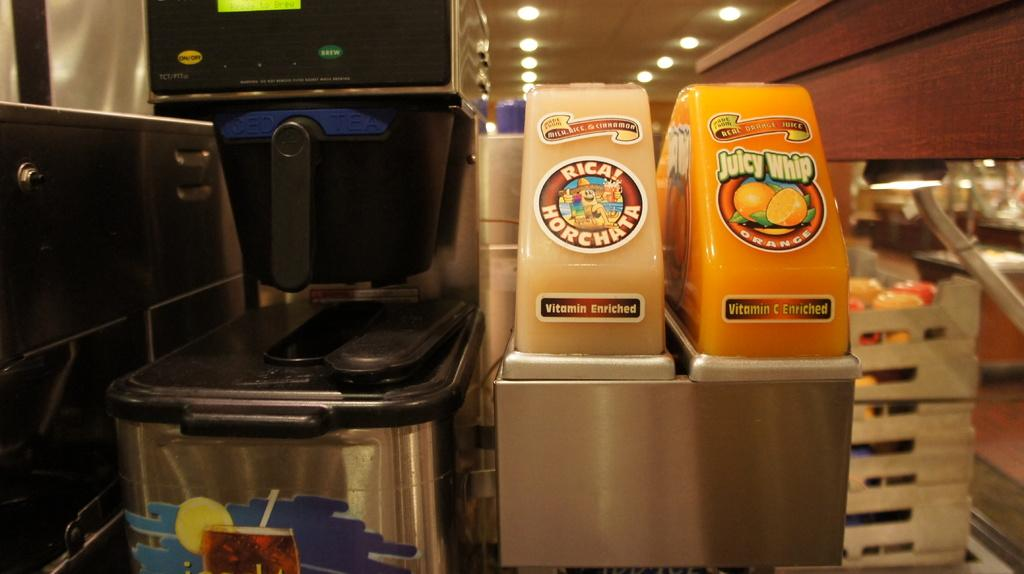Provide a one-sentence caption for the provided image. Two beverage dispensers with one of them offering Juicy Whip. 